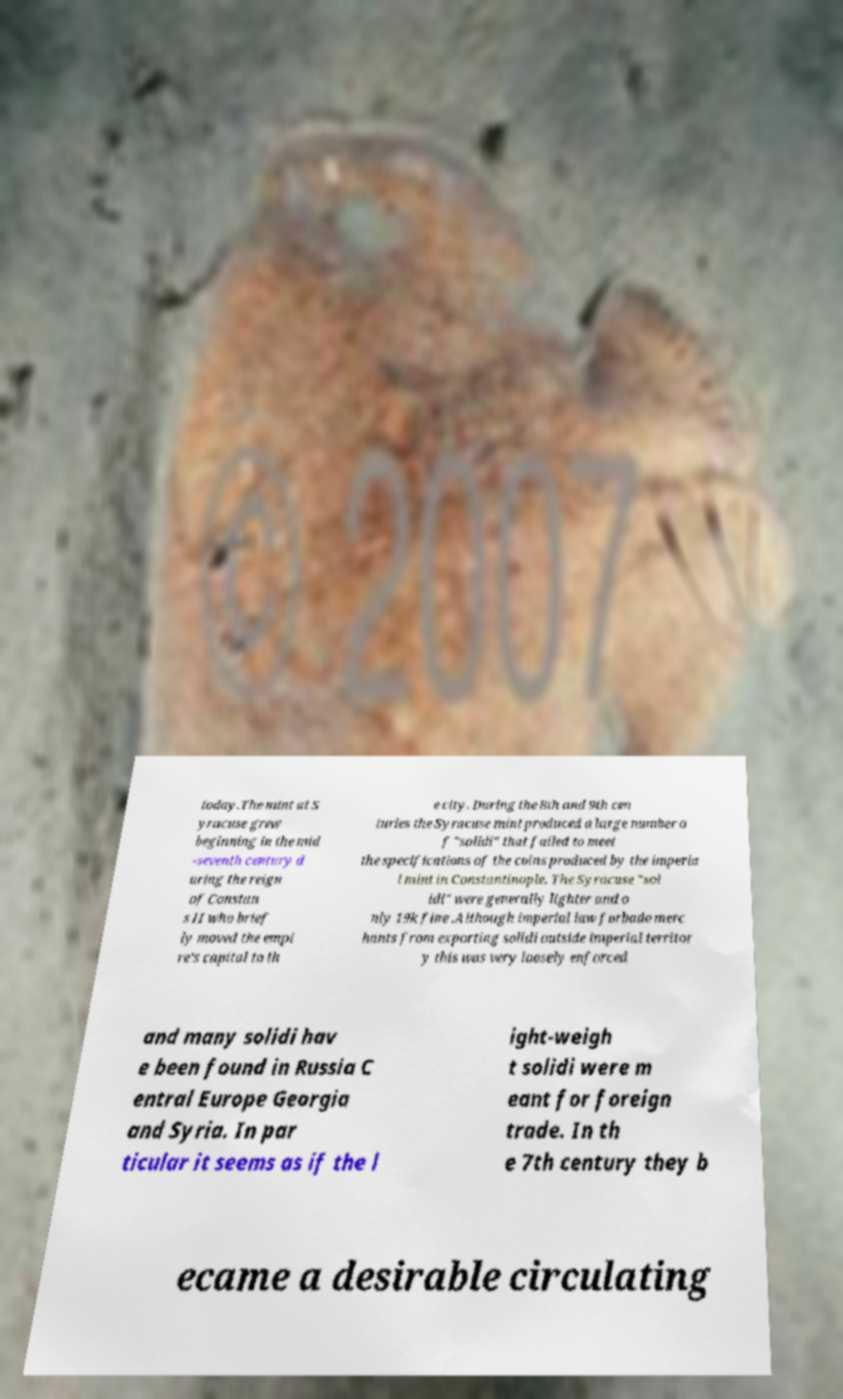For documentation purposes, I need the text within this image transcribed. Could you provide that? today.The mint at S yracuse grew beginning in the mid -seventh century d uring the reign of Constan s II who brief ly moved the empi re's capital to th e city. During the 8th and 9th cen turies the Syracuse mint produced a large number o f "solidi" that failed to meet the specifications of the coins produced by the imperia l mint in Constantinople. The Syracuse "sol idi" were generally lighter and o nly 19k fine .Although imperial law forbade merc hants from exporting solidi outside imperial territor y this was very loosely enforced and many solidi hav e been found in Russia C entral Europe Georgia and Syria. In par ticular it seems as if the l ight-weigh t solidi were m eant for foreign trade. In th e 7th century they b ecame a desirable circulating 